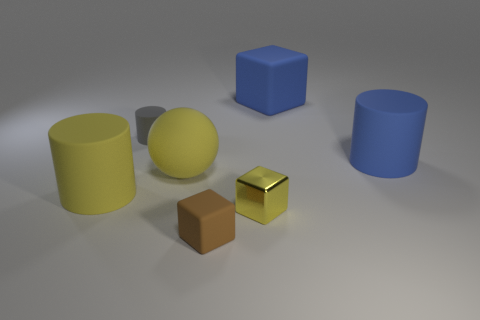There is a object that is to the right of the tiny yellow metallic object and in front of the small gray thing; what color is it?
Keep it short and to the point. Blue. Is the size of the brown matte thing the same as the yellow metal thing?
Ensure brevity in your answer.  Yes. There is a tiny rubber thing that is behind the big yellow rubber ball; what is its color?
Provide a short and direct response. Gray. Are there any big cylinders that have the same color as the large block?
Your response must be concise. Yes. There is a cylinder that is the same size as the metal cube; what is its color?
Give a very brief answer. Gray. Is the shape of the tiny yellow metallic thing the same as the gray thing?
Offer a terse response. No. What is the large yellow ball that is on the left side of the small yellow cube made of?
Keep it short and to the point. Rubber. The big rubber cube has what color?
Ensure brevity in your answer.  Blue. There is a rubber block left of the large rubber block; is it the same size as the cylinder to the right of the blue matte block?
Provide a succinct answer. No. There is a matte cylinder that is both in front of the gray rubber cylinder and to the left of the tiny brown object; how big is it?
Make the answer very short. Large. 